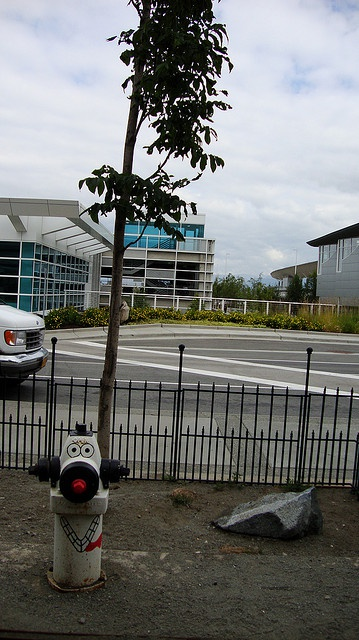Describe the objects in this image and their specific colors. I can see fire hydrant in lightgray, black, gray, and darkgray tones and truck in lightgray, black, gray, and darkgray tones in this image. 